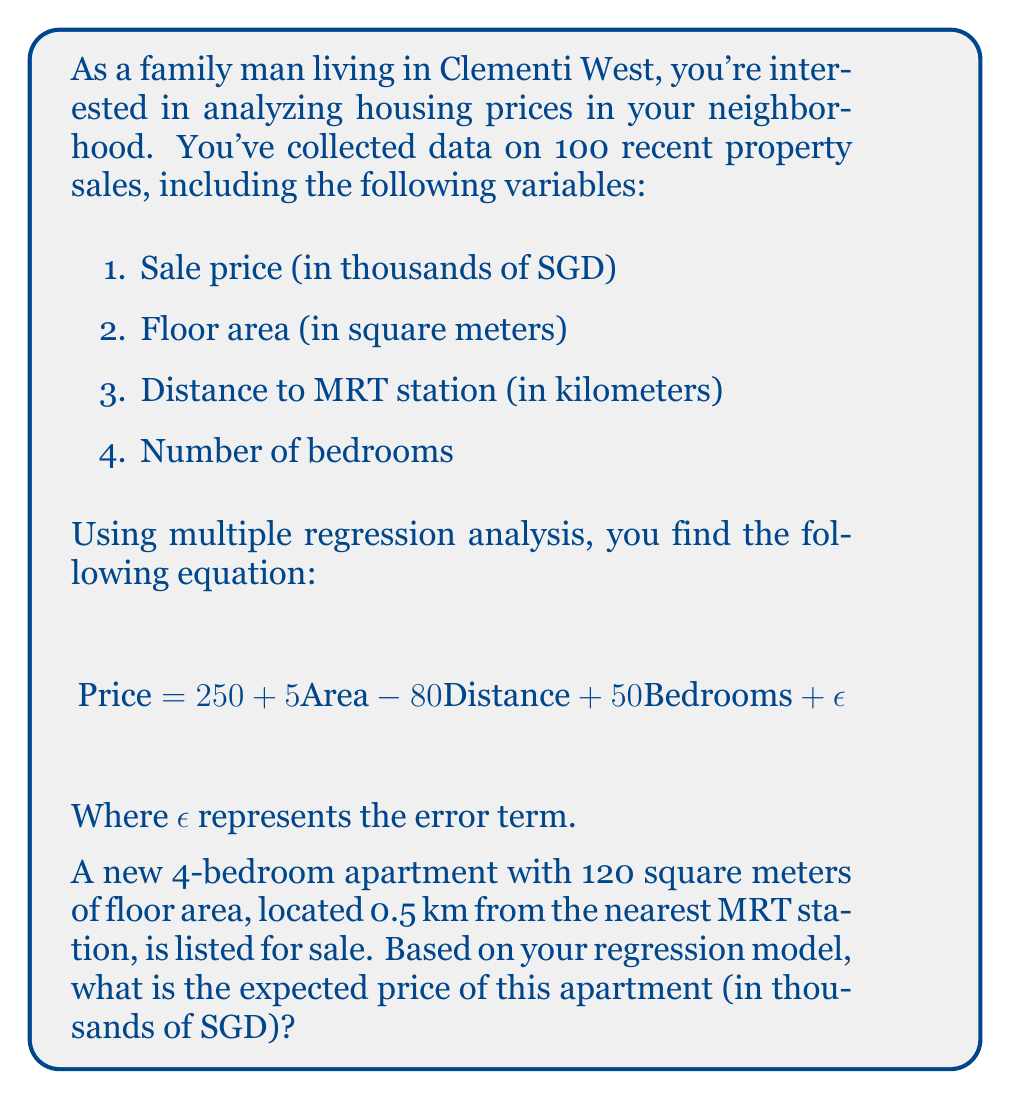Help me with this question. To solve this problem, we'll use the multiple regression equation provided and plug in the values for our new apartment:

1. Area = 120 sq meters
2. Distance to MRT = 0.5 km
3. Number of bedrooms = 4

Let's substitute these values into the equation:

$$\text{Price} = 250 + 5\text{Area} - 80\text{Distance} + 50\text{Bedrooms} + \epsilon$$

$$\text{Price} = 250 + 5(120) - 80(0.5) + 50(4) + \epsilon$$

Now, let's calculate each term:

1. Constant term: 250
2. Area term: $5 \times 120 = 600$
3. Distance term: $-80 \times 0.5 = -40$
4. Bedrooms term: $50 \times 4 = 200$

Adding these terms:

$$\text{Price} = 250 + 600 - 40 + 200 + \epsilon$$
$$\text{Price} = 1010 + \epsilon$$

Since $\epsilon$ represents the error term and we're looking for the expected price, we can ignore it in our final calculation.

Therefore, the expected price of the apartment is 1010 thousand SGD, or 1,010,000 SGD.
Answer: 1,010,000 SGD 